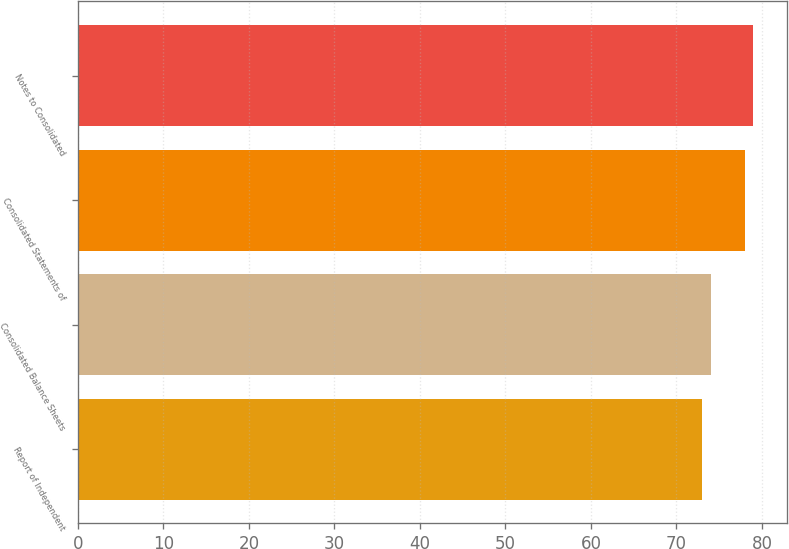<chart> <loc_0><loc_0><loc_500><loc_500><bar_chart><fcel>Report of Independent<fcel>Consolidated Balance Sheets<fcel>Consolidated Statements of<fcel>Notes to Consolidated<nl><fcel>73<fcel>74<fcel>78<fcel>79<nl></chart> 